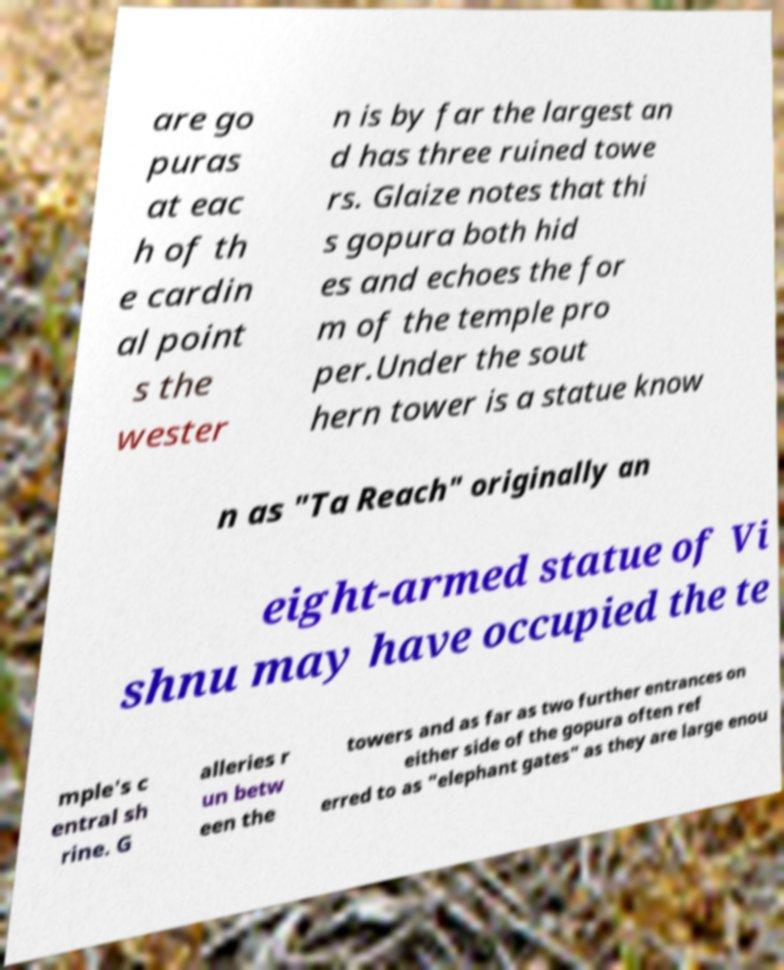For documentation purposes, I need the text within this image transcribed. Could you provide that? are go puras at eac h of th e cardin al point s the wester n is by far the largest an d has three ruined towe rs. Glaize notes that thi s gopura both hid es and echoes the for m of the temple pro per.Under the sout hern tower is a statue know n as "Ta Reach" originally an eight-armed statue of Vi shnu may have occupied the te mple's c entral sh rine. G alleries r un betw een the towers and as far as two further entrances on either side of the gopura often ref erred to as "elephant gates" as they are large enou 